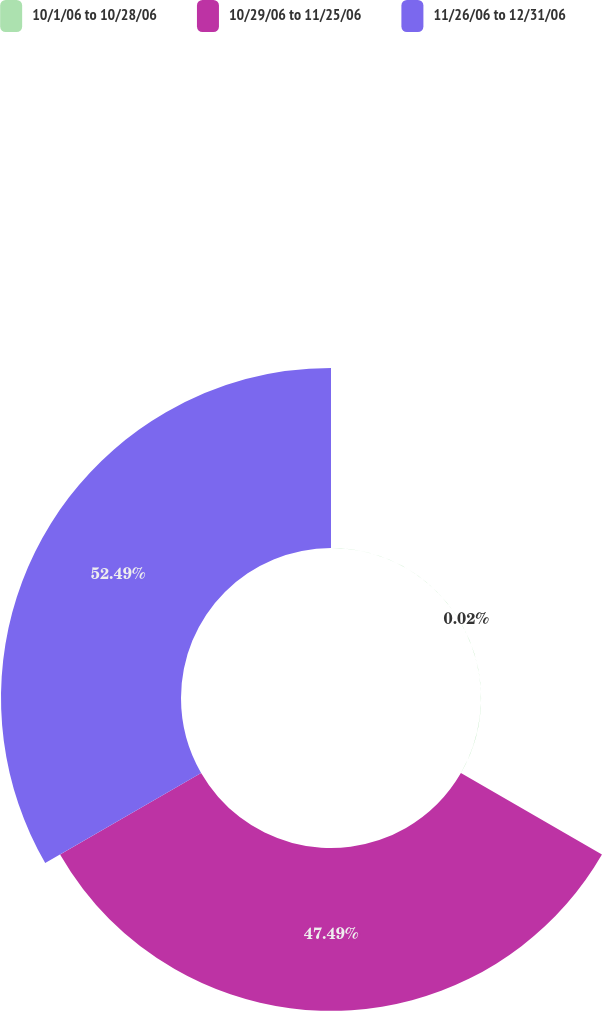Convert chart. <chart><loc_0><loc_0><loc_500><loc_500><pie_chart><fcel>10/1/06 to 10/28/06<fcel>10/29/06 to 11/25/06<fcel>11/26/06 to 12/31/06<nl><fcel>0.02%<fcel>47.49%<fcel>52.49%<nl></chart> 